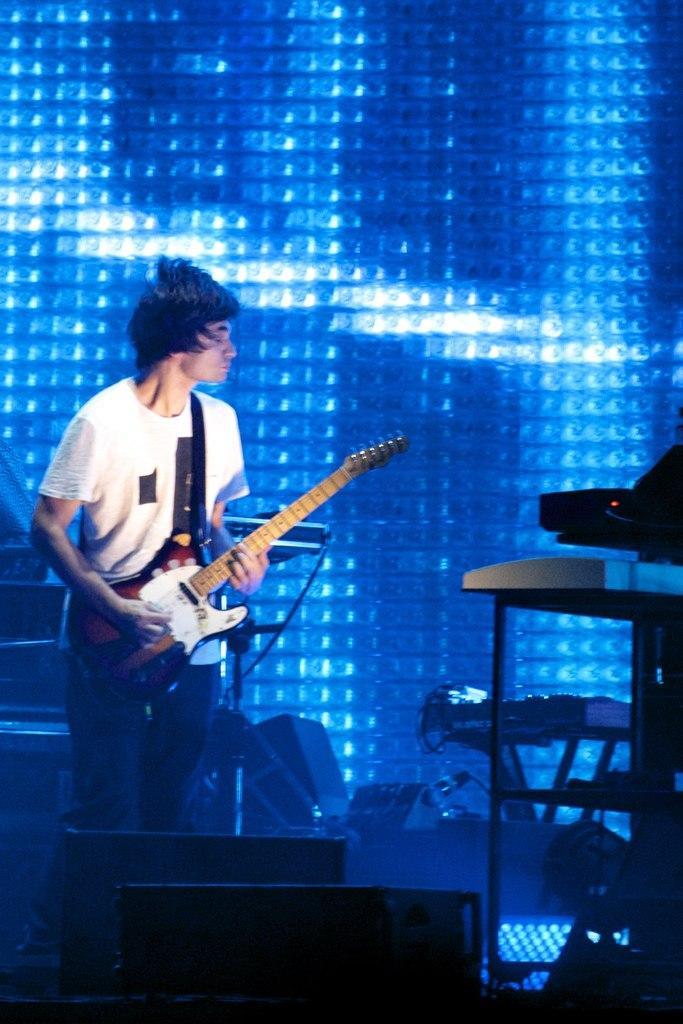Could you give a brief overview of what you see in this image? In the image we can see a man wearing clothes and holding a guitar in hand. This is a cable wire and we can see there are even musical instruments, this is a background light. 